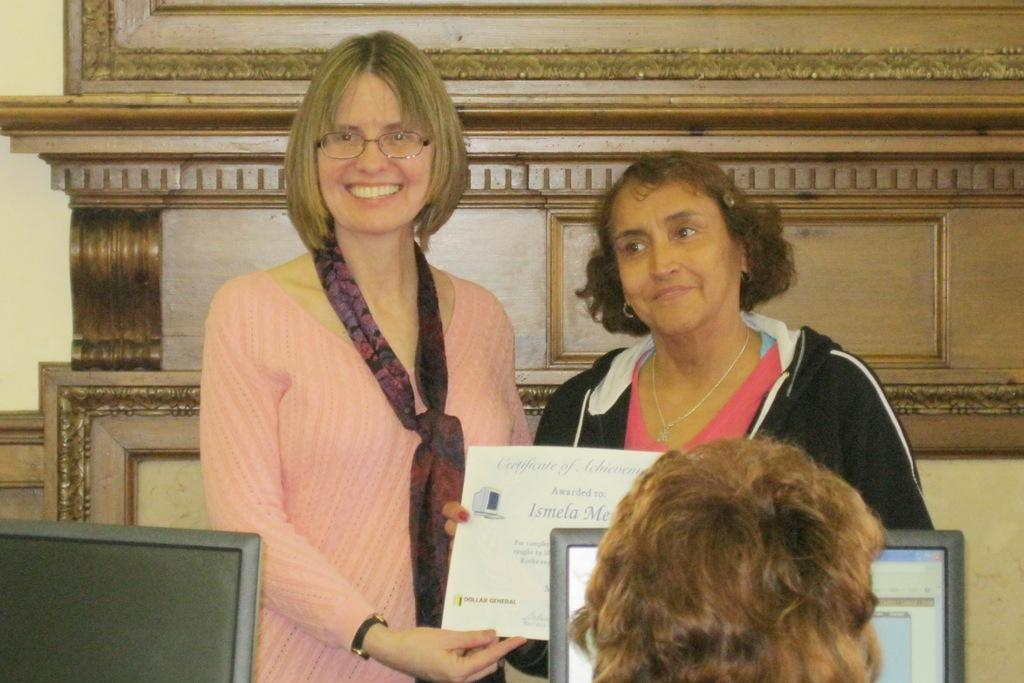How many monitors are visible in the image? There are 2 monitors in the image. What is the person in the image doing? The person is sitting in the image. How many women are standing in the image? There are 2 women standing in the image. What are the women holding? The women are holding a certificate. Can you describe the appearance of the woman on the left? The woman on the left is wearing spectacles and is smiling. Can you tell me how many times the person in the image has flown to the moon? There is no information about the person flying to the moon in the image. What type of skirt is the woman on the right wearing? There is no mention of a skirt in the image. 